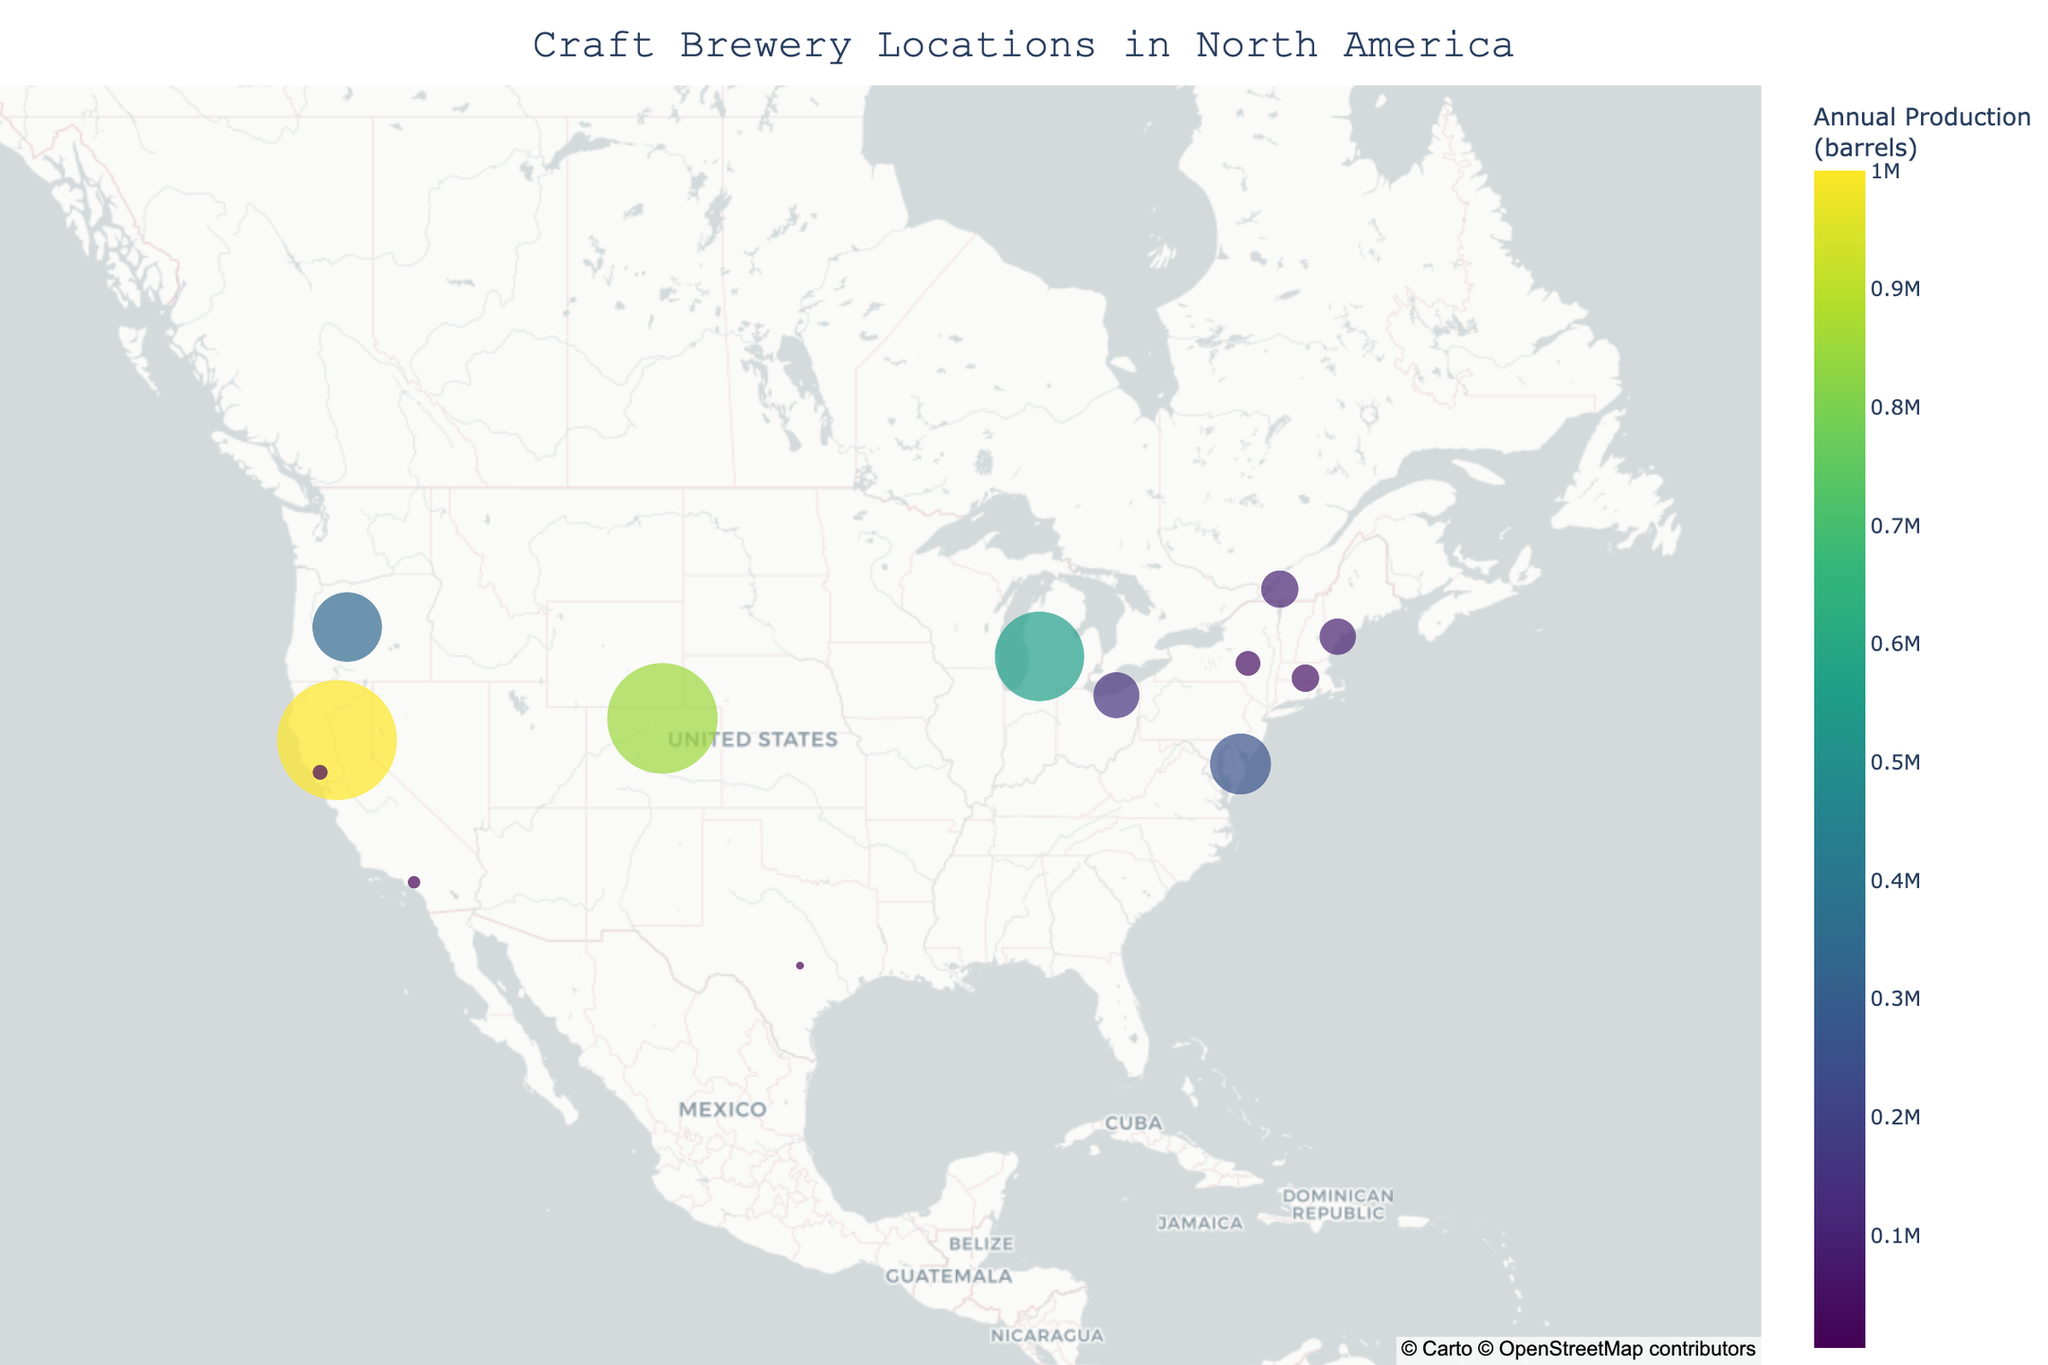How many breweries are shown in the figure? Count the number of data points (breweries) represented on the map.
Answer: 13 Which brewery appears to have the highest annual production? Look for the largest circle on the map, which indicates the brewery with the highest annual production.
Answer: Sierra Nevada Brewing Co What is the title of this geographic plot? Read the title displayed at the top of the figure.
Answer: Craft Brewery Locations in North America Which region in the USA has the highest concentration of breweries according to the map? Identify the grouping of circles within the USA with the shortest distances between them.
Answer: California How does the annual production of Deschutes Brewery compare to Jester King Brewery? Compare the sizes of the circles for Deschutes Brewery and Jester King Brewery. Deschutes Brewery's circle is significantly larger than Jester King Brewery's, indicating a higher annual production.
Answer: Deschutes Brewery has a higher annual production Which country's breweries are represented on the map? Look at the geographic locations of the circles and note the countries mentioned in the hover details.
Answer: USA and Canada What is the average annual production of the breweries in California? Add the annual production of all breweries in California and divide by the number of breweries. The breweries in California are Sierra Nevada Brewing Co., Russian River Brewing Company, and The Bruery with productions of 1,000,000, 17,000, and 12,000 barrels respectively. \( \frac{1,000,000 + 17,000 + 12,000}{3} = 343,000 \) barrels.
Answer: 343,000 barrels Which brewery has the smallest annual production, and where is it located? Identify the smallest circle on the map and review its hover data to find the name and location.
Answer: Jester King Brewery, Austin, Texas What is the hover data displayed for Unibroue? Hover over the circle representing Unibroue and read the displayed information.
Answer: City: Chambly, State/Province: Quebec, Annual Production: 100,000 barrels How many breweries have an annual production of over 500,000 barrels? Count the number of circles representing breweries with productions over 500,000 barrels based on their sizes and hover data.
Answer: 3 